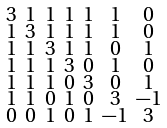<formula> <loc_0><loc_0><loc_500><loc_500>\begin{smallmatrix} 3 & 1 & 1 & 1 & 1 & 1 & 0 \\ 1 & 3 & 1 & 1 & 1 & 1 & 0 \\ 1 & 1 & 3 & 1 & 1 & 0 & 1 \\ 1 & 1 & 1 & 3 & 0 & 1 & 0 \\ 1 & 1 & 1 & 0 & 3 & 0 & 1 \\ 1 & 1 & 0 & 1 & 0 & 3 & - 1 \\ 0 & 0 & 1 & 0 & 1 & - 1 & 3 \end{smallmatrix}</formula> 